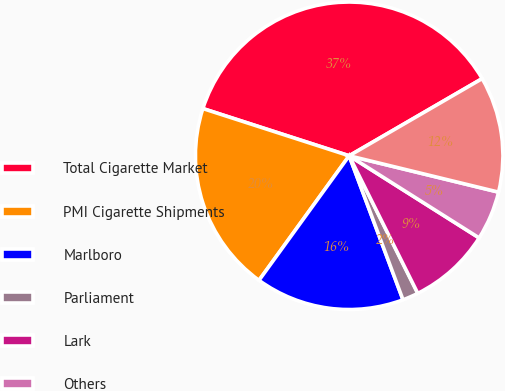<chart> <loc_0><loc_0><loc_500><loc_500><pie_chart><fcel>Total Cigarette Market<fcel>PMI Cigarette Shipments<fcel>Marlboro<fcel>Parliament<fcel>Lark<fcel>Others<fcel>Total<nl><fcel>36.67%<fcel>20.0%<fcel>15.67%<fcel>1.67%<fcel>8.67%<fcel>5.17%<fcel>12.17%<nl></chart> 